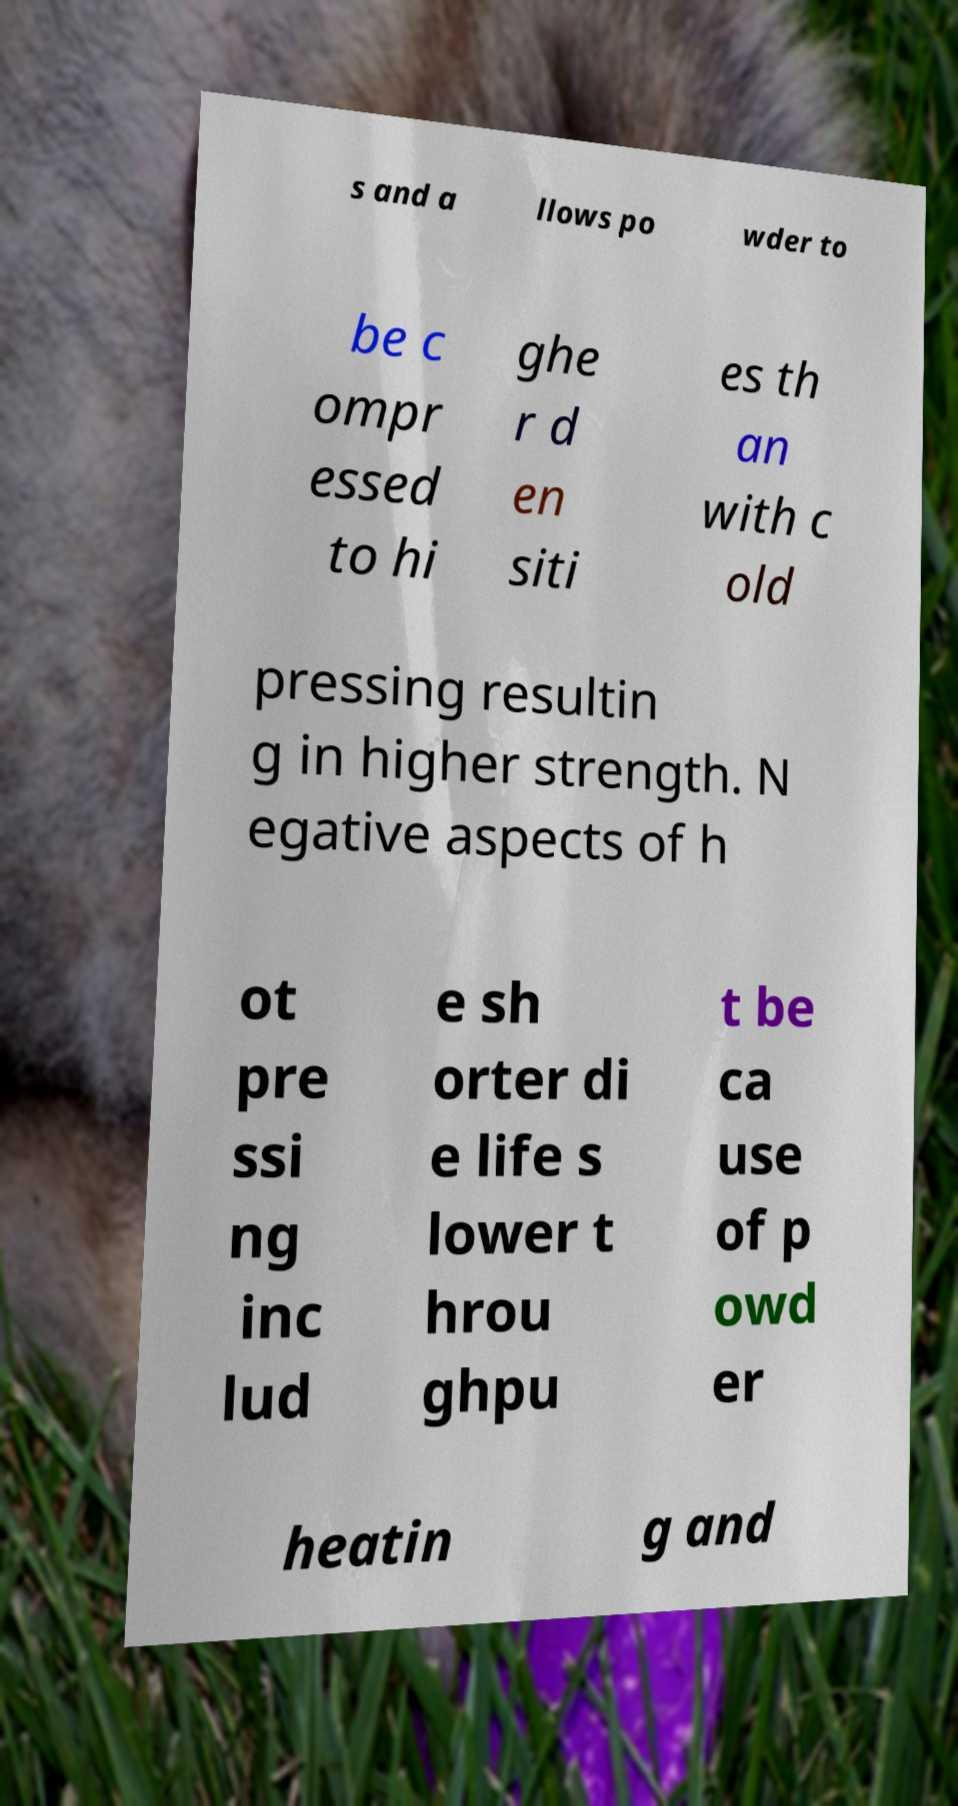For documentation purposes, I need the text within this image transcribed. Could you provide that? s and a llows po wder to be c ompr essed to hi ghe r d en siti es th an with c old pressing resultin g in higher strength. N egative aspects of h ot pre ssi ng inc lud e sh orter di e life s lower t hrou ghpu t be ca use of p owd er heatin g and 